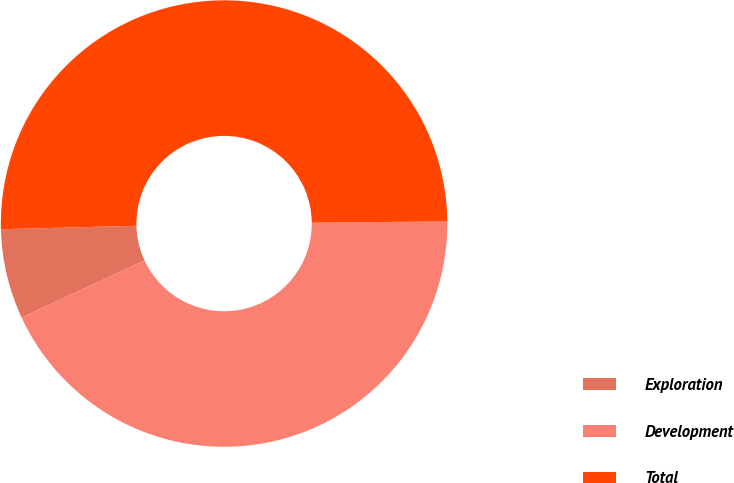<chart> <loc_0><loc_0><loc_500><loc_500><pie_chart><fcel>Exploration<fcel>Development<fcel>Total<nl><fcel>6.51%<fcel>43.24%<fcel>50.25%<nl></chart> 